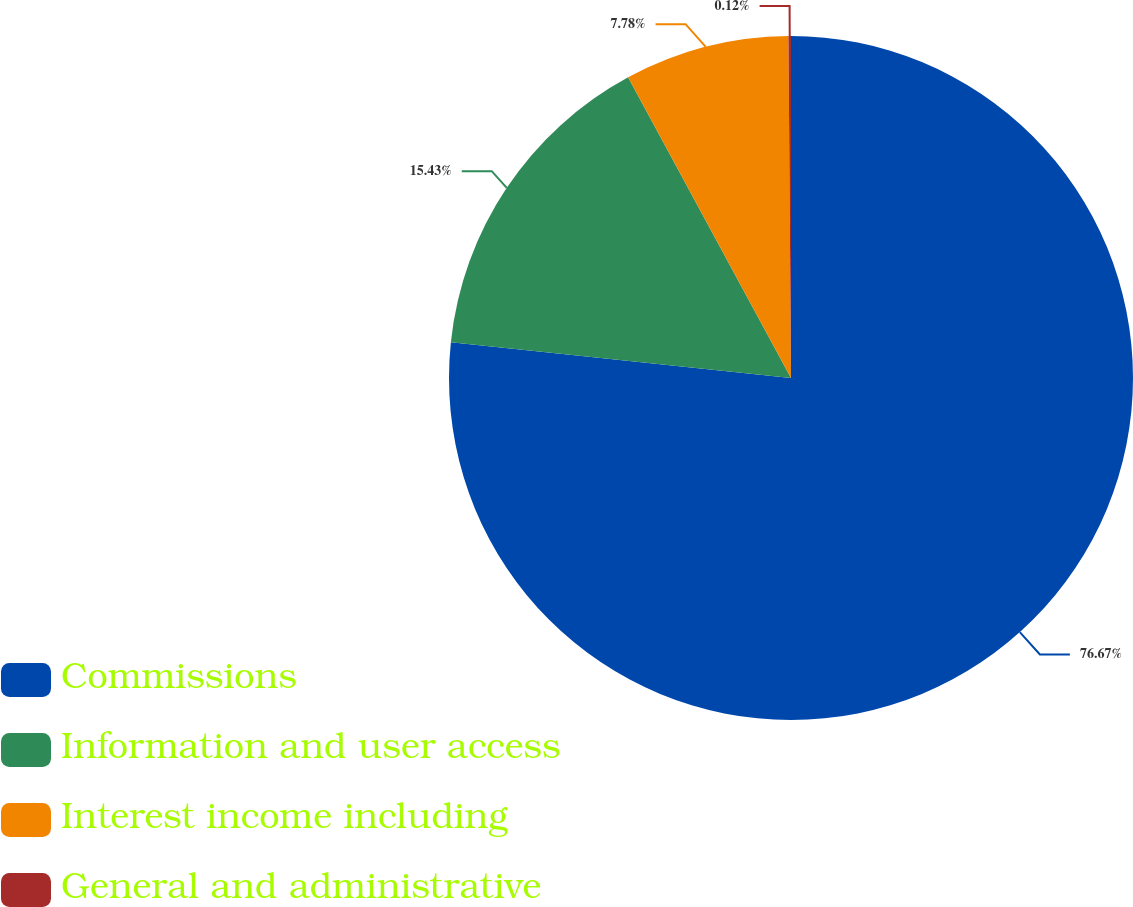Convert chart to OTSL. <chart><loc_0><loc_0><loc_500><loc_500><pie_chart><fcel>Commissions<fcel>Information and user access<fcel>Interest income including<fcel>General and administrative<nl><fcel>76.67%<fcel>15.43%<fcel>7.78%<fcel>0.12%<nl></chart> 